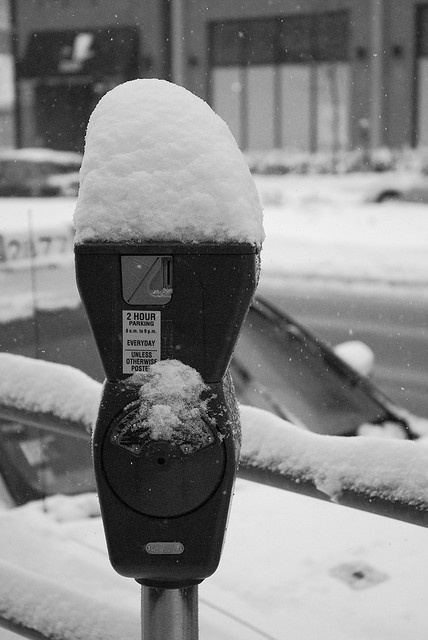Describe the objects in this image and their specific colors. I can see car in gray, lightgray, darkgray, and black tones, parking meter in gray, black, darkgray, and lightgray tones, car in gray, darkgray, lightgray, and black tones, and car in gray, darkgray, lightgray, and black tones in this image. 